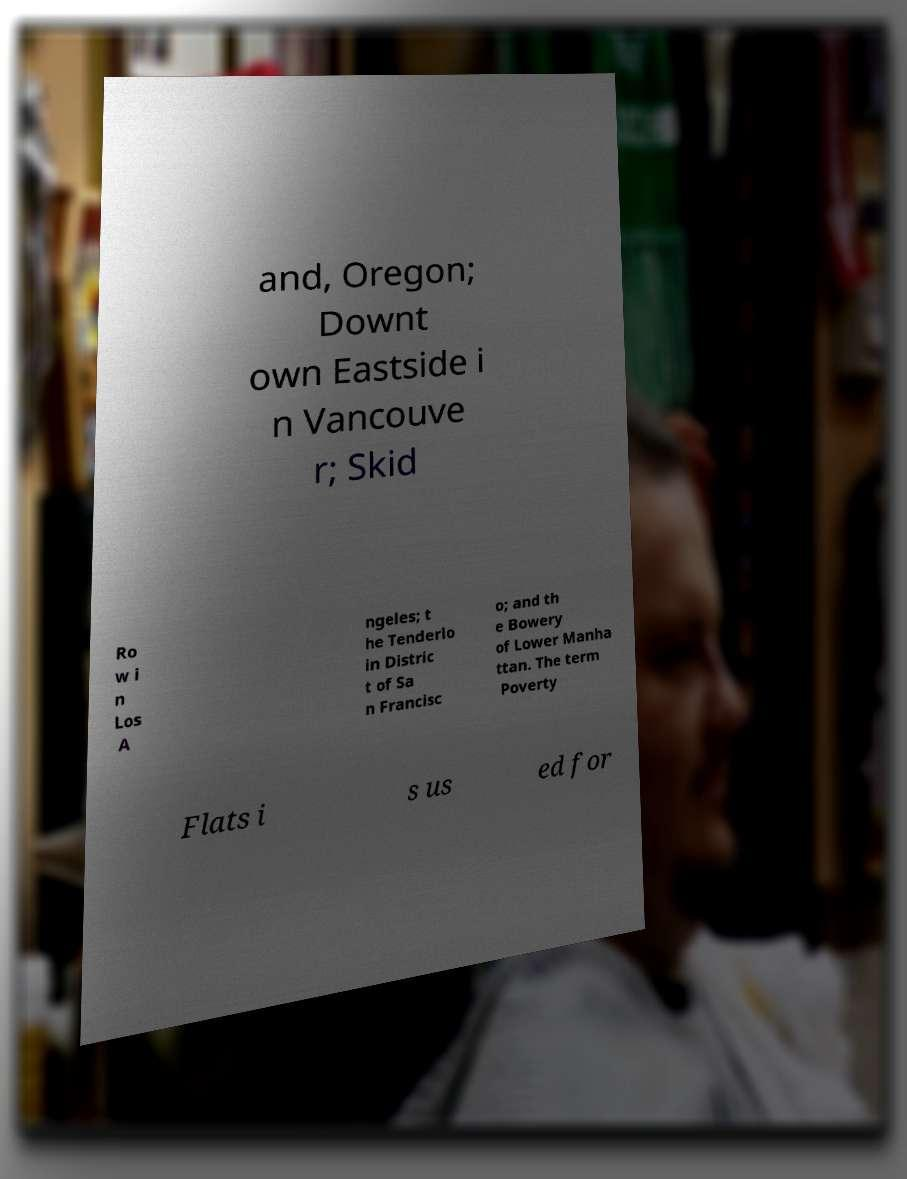Please read and relay the text visible in this image. What does it say? and, Oregon; Downt own Eastside i n Vancouve r; Skid Ro w i n Los A ngeles; t he Tenderlo in Distric t of Sa n Francisc o; and th e Bowery of Lower Manha ttan. The term Poverty Flats i s us ed for 